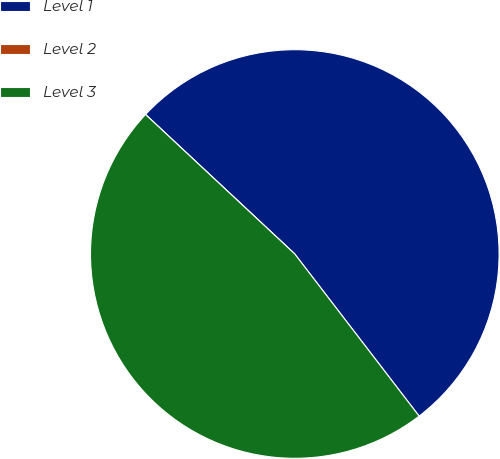Convert chart to OTSL. <chart><loc_0><loc_0><loc_500><loc_500><pie_chart><fcel>Level 1<fcel>Level 2<fcel>Level 3<nl><fcel>52.62%<fcel>0.0%<fcel>47.37%<nl></chart> 